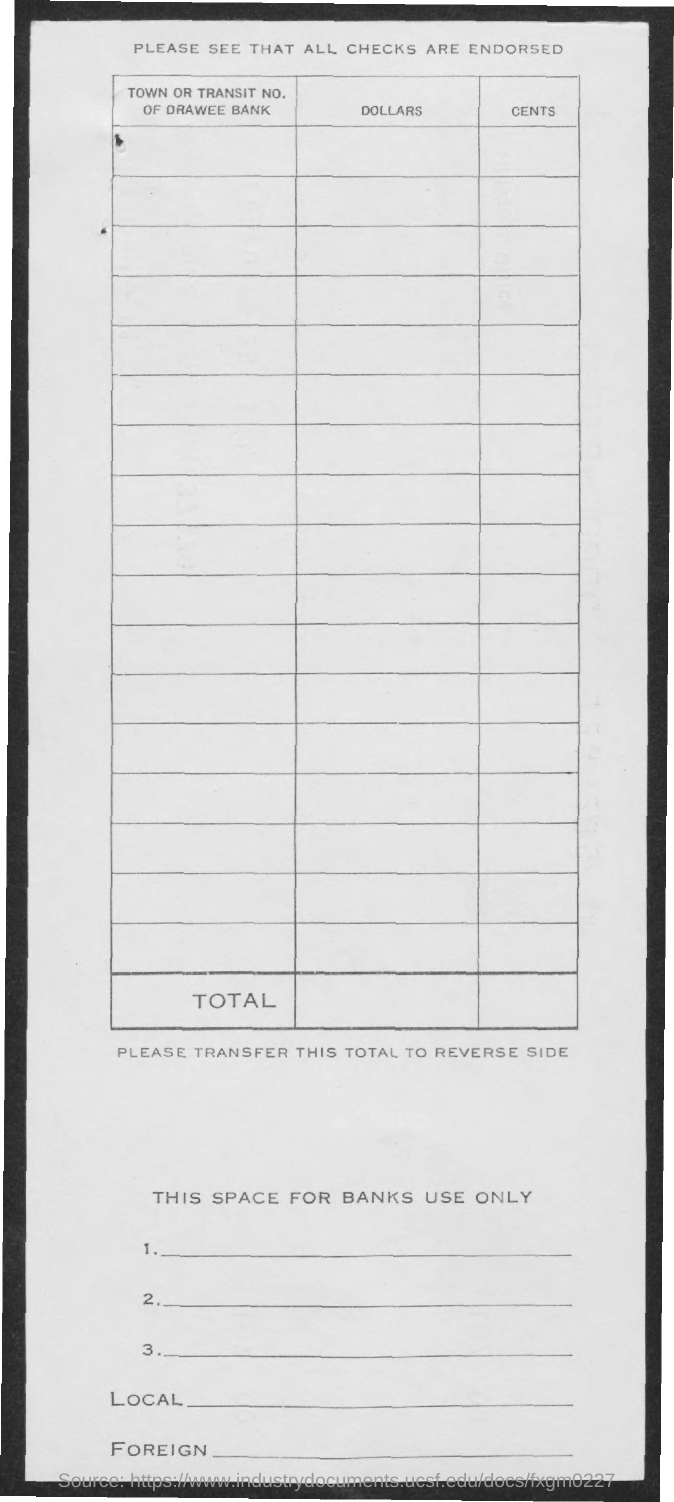Highlight a few significant elements in this photo. The information written below the table needs to be transferred to the reverse side. The document states that the checks mentioned above have been endorsed. The heading for the first column is 'Town' or 'Transit No. Of drawee bank.' 